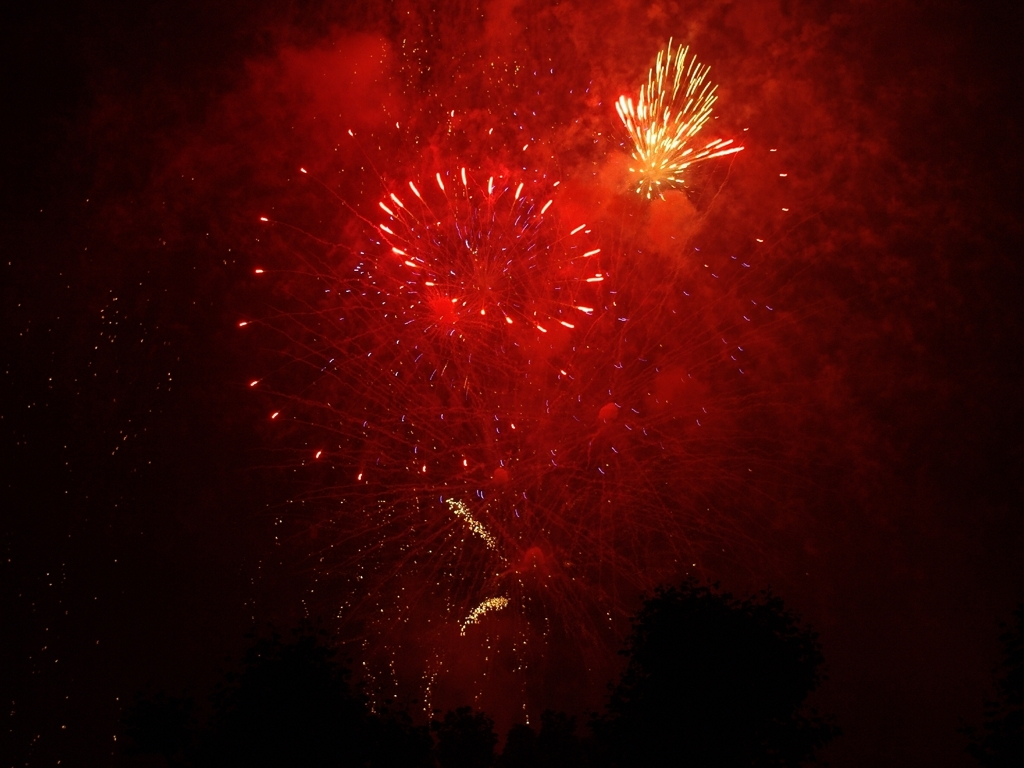How could the photograph have been improved in terms of composition and lighting? To enhance the composition, the photographer might have chosen a perspective that includes more of the foreground or a cityscape to give context to the fireworks. For lighting, using a slower shutter speed could capture more light trails, adding to the dynamism and festive feel of the image. 